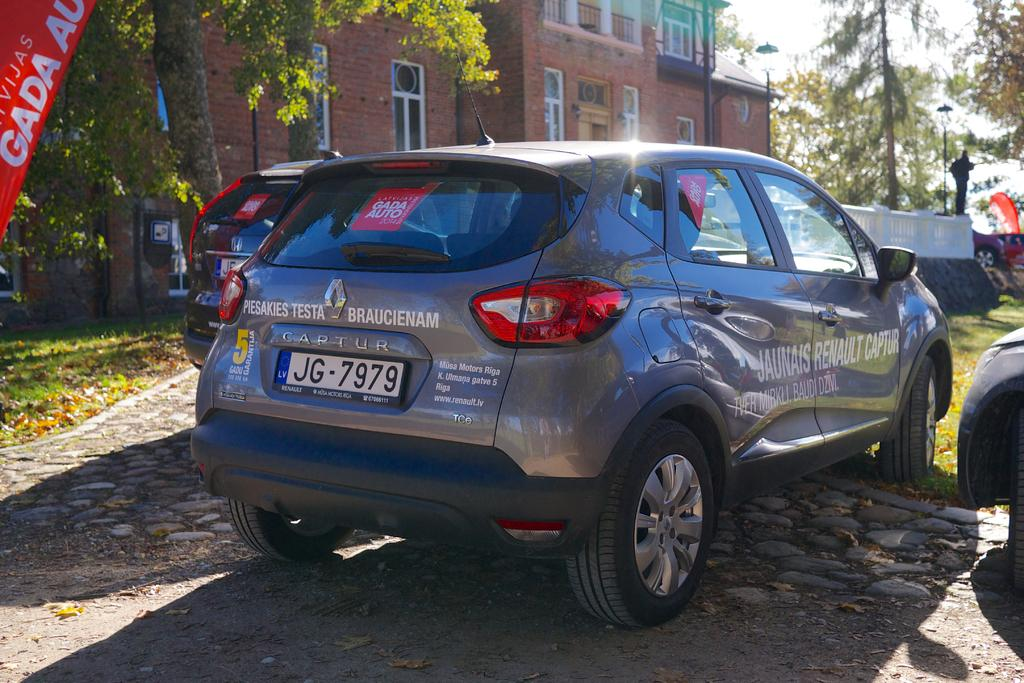What can be seen on the surface in the image? There are cars on the surface in the image. What is hanging or displayed in the image? There is a banner in the image. What type of vegetation is present in the image? There is grass and leaves in the image. What structures can be seen in the background of the image? There is a building, trees, poles, a fence, and windows in the background of the image. What part of the natural environment is visible in the image? The sky is visible in the background of the image. What type of skin condition can be seen on the cars in the image? There is no skin condition present in the image, as the cars are inanimate objects. What observation can be made about the point of the image? The image does not have a specific point or purpose, as it is a still photograph. 